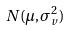<formula> <loc_0><loc_0><loc_500><loc_500>N ( \mu , \sigma _ { v } ^ { 2 } )</formula> 